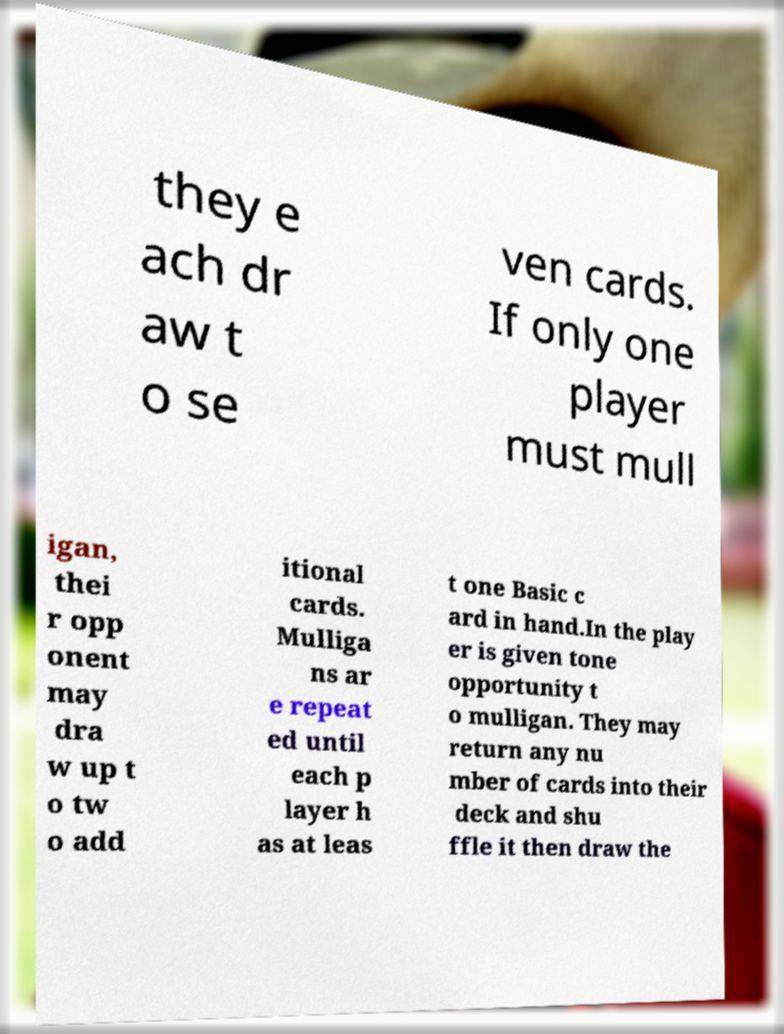Please read and relay the text visible in this image. What does it say? they e ach dr aw t o se ven cards. If only one player must mull igan, thei r opp onent may dra w up t o tw o add itional cards. Mulliga ns ar e repeat ed until each p layer h as at leas t one Basic c ard in hand.In the play er is given tone opportunity t o mulligan. They may return any nu mber of cards into their deck and shu ffle it then draw the 